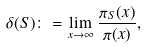<formula> <loc_0><loc_0><loc_500><loc_500>\delta ( S ) \colon = \lim _ { x \to \infty } \frac { \pi _ { S } ( x ) } { \pi ( x ) } ,</formula> 